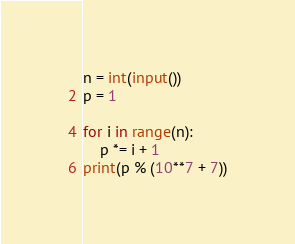<code> <loc_0><loc_0><loc_500><loc_500><_Python_>n = int(input())
p = 1

for i in range(n):
    p *= i + 1
print(p % (10**7 + 7))</code> 